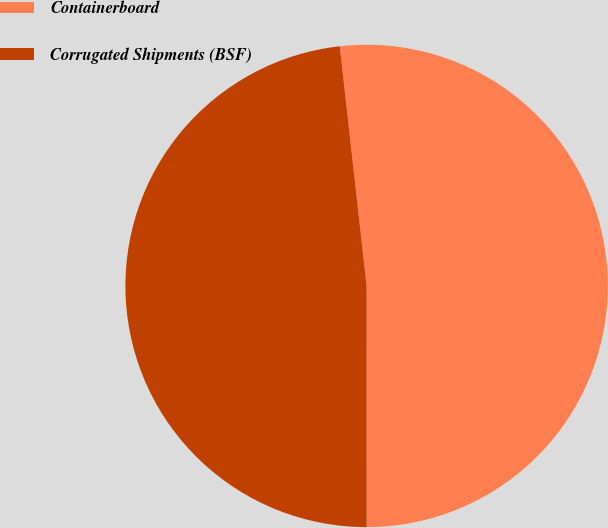Convert chart to OTSL. <chart><loc_0><loc_0><loc_500><loc_500><pie_chart><fcel>Containerboard<fcel>Corrugated Shipments (BSF)<nl><fcel>51.77%<fcel>48.23%<nl></chart> 